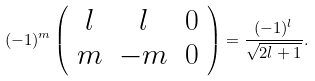<formula> <loc_0><loc_0><loc_500><loc_500>( - 1 ) ^ { m } \left ( \begin{array} { c c c } l & l & 0 \\ m & - m & 0 \end{array} \right ) = \frac { ( - 1 ) ^ { l } } { \sqrt { 2 l + 1 } } .</formula> 